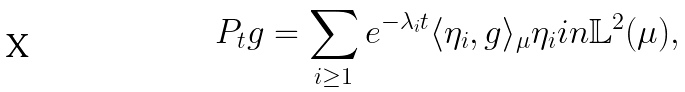<formula> <loc_0><loc_0><loc_500><loc_500>P _ { t } g = \sum _ { i \geq 1 } e ^ { - \lambda _ { i } t } \langle \eta _ { i } , g \rangle _ { \mu } \eta _ { i } i n \mathbb { L } ^ { 2 } ( \mu ) ,</formula> 